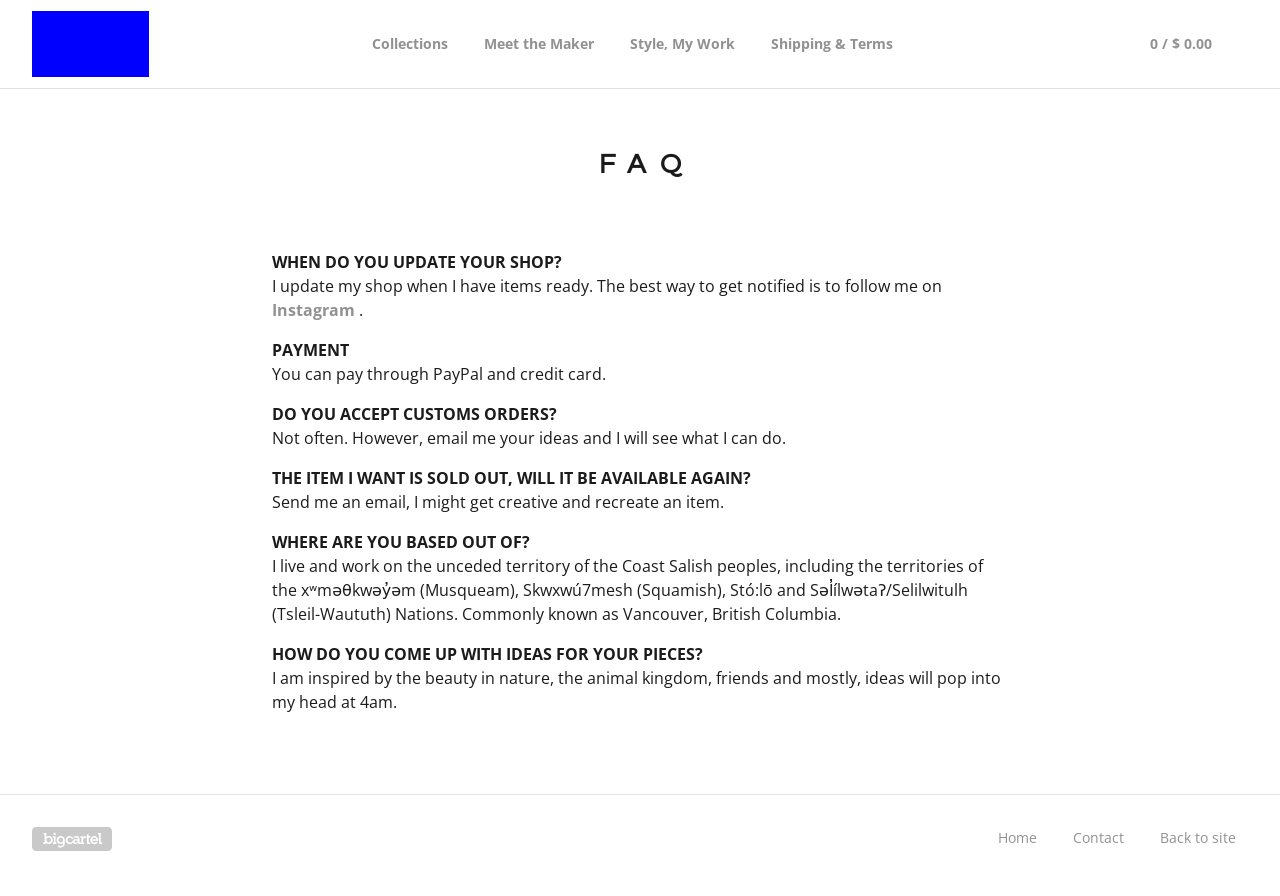Could you detail the process for assembling this website using HTML? To build a FAQ page like the one shown in the image using HTML, you would start by defining a basic HTML structure with a `<!DOCTYPE html>` tag, followed by `<html>` and `<body>` elements. Within the body, you can use `<div>` tags to create sections such as the header, navigation bar, and main content area where the FAQ items are listed. Each FAQ can be inside its own `<div>` or `<section>` for better structure and styling, and you can use `<p>` or `<h2>` tags for the questions with `<p>` tags for the answers to ensure they are well organized. CSS would typically be used to style these elements, controlling the layout, fonts, and colors to match the design seen in the image. 